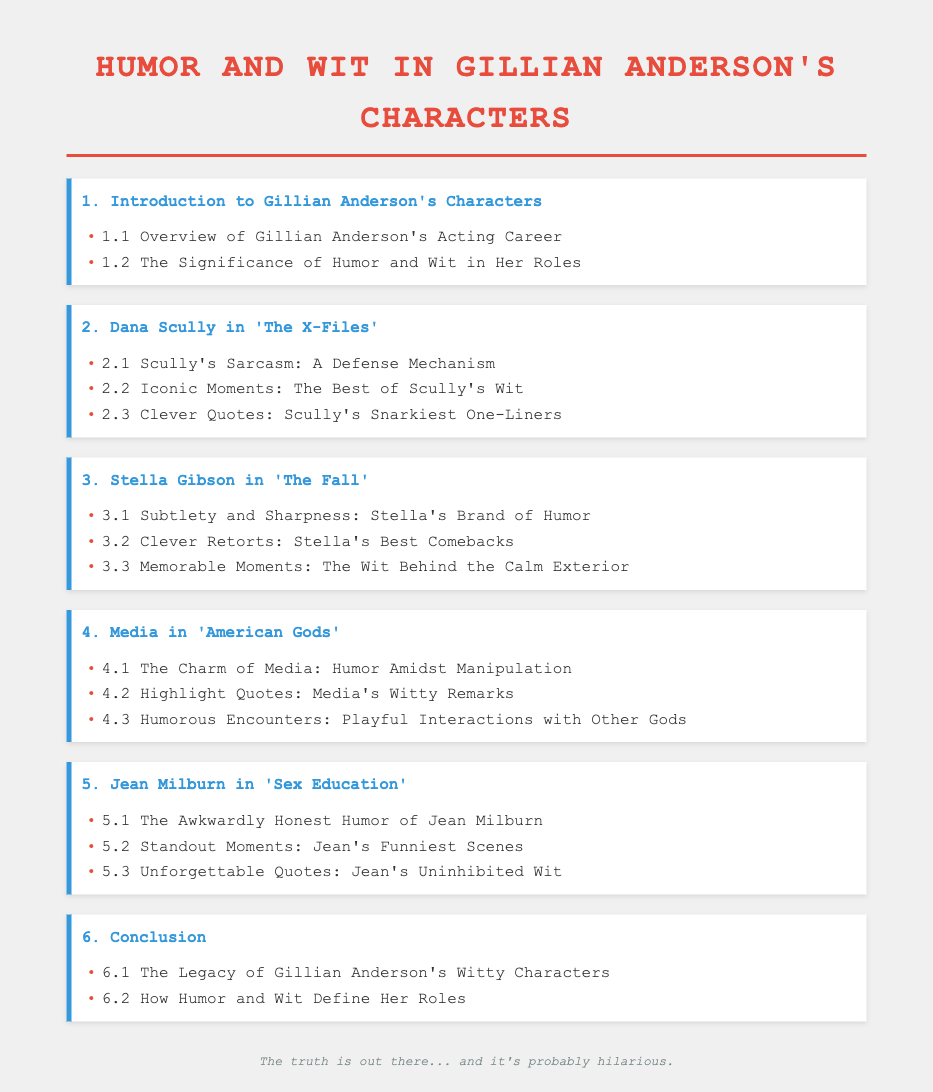What is the title of the document? The title is presented prominently at the top of the document.
Answer: Humor and Wit in Gillian Anderson's Characters How many main chapters are in the document? The number of chapters is counted from the table of contents.
Answer: 6 Which character is featured in the section about clever quotes? The section specifically mentions a character known for wit and clever remarks.
Answer: Dana Scully What is the subtitle of the chapter on Jean Milburn? Each chapter has a title along with specific topics covered within it.
Answer: The Awkwardly Honest Humor of Jean Milburn What is the last section of the document? The final section wraps up the themes discussed throughout the document.
Answer: How Humor and Wit Define Her Roles Which character is associated with "The Fall"? The chapter title indicates which character is the focus of that section.
Answer: Stella Gibson 